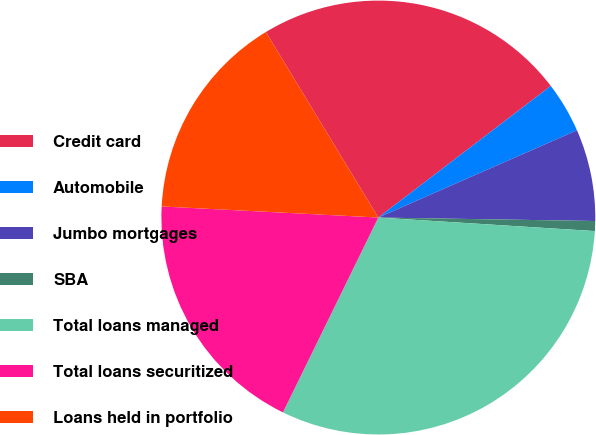Convert chart to OTSL. <chart><loc_0><loc_0><loc_500><loc_500><pie_chart><fcel>Credit card<fcel>Automobile<fcel>Jumbo mortgages<fcel>SBA<fcel>Total loans managed<fcel>Total loans securitized<fcel>Loans held in portfolio<nl><fcel>23.3%<fcel>3.79%<fcel>6.84%<fcel>0.74%<fcel>31.25%<fcel>18.57%<fcel>15.51%<nl></chart> 